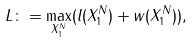<formula> <loc_0><loc_0><loc_500><loc_500>L \colon = \max _ { X _ { 1 } ^ { N } } ( l ( X _ { 1 } ^ { N } ) + w ( X _ { 1 } ^ { N } ) ) ,</formula> 